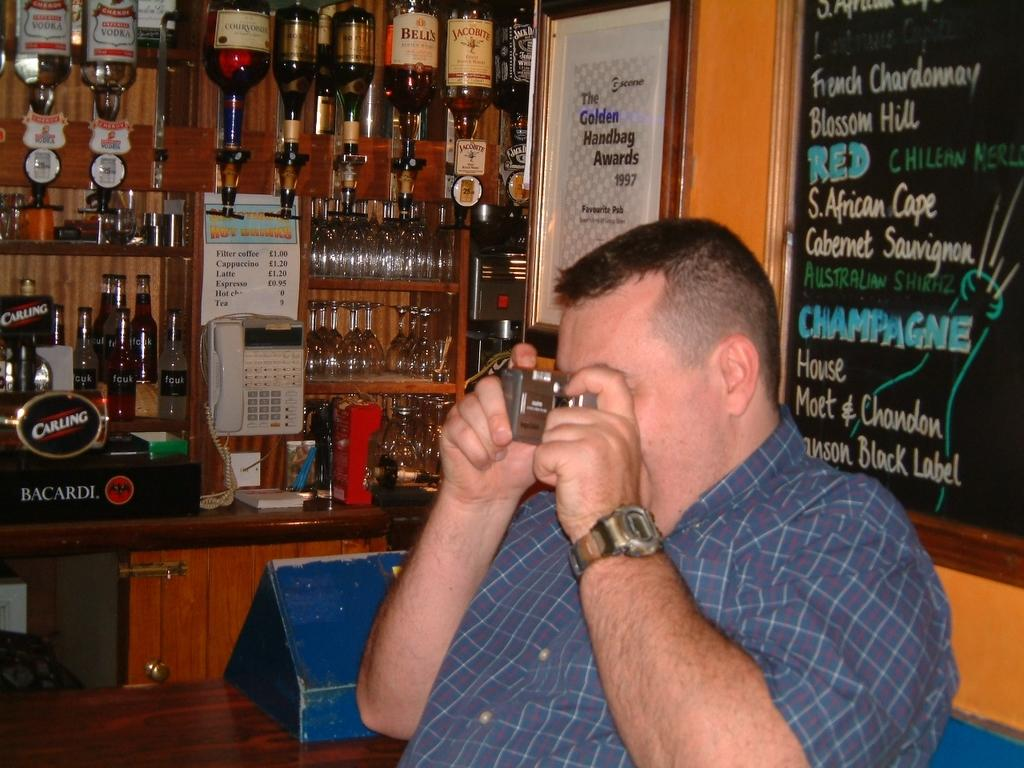What is the man in the image holding? The man is holding a camera. What can be seen in the background of the image? In the background, there is a notice board, bottles, glasses, and a telephone. What might the man be doing with the camera? The man might be taking photographs or recording a video. What type of verse can be seen written on the notice board in the image? There is no verse visible on the notice board in the image. What color is the copper mailbox in the image? There is no mailbox, let alone a copper one, present in the image. 